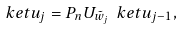Convert formula to latex. <formula><loc_0><loc_0><loc_500><loc_500>\ k e t { u _ { j } } = P _ { n } U _ { \tilde { w } _ { j } } \ k e t { u _ { j - 1 } } ,</formula> 